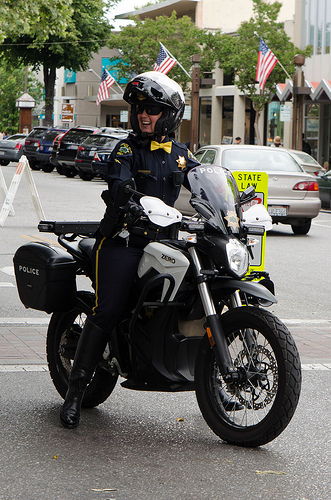<image>
Can you confirm if the bowtie is on the police officer? Yes. Looking at the image, I can see the bowtie is positioned on top of the police officer, with the police officer providing support. Is the motorcycle next to the car? No. The motorcycle is not positioned next to the car. They are located in different areas of the scene. 